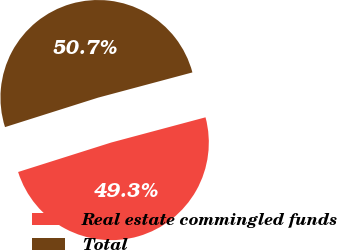<chart> <loc_0><loc_0><loc_500><loc_500><pie_chart><fcel>Real estate commingled funds<fcel>Total<nl><fcel>49.28%<fcel>50.72%<nl></chart> 